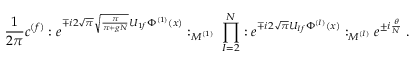Convert formula to latex. <formula><loc_0><loc_0><loc_500><loc_500>\frac { 1 } { 2 \pi } c ^ { ( f ) } \colon e ^ { \mp i 2 \sqrt { \pi } \sqrt { \frac { \pi } { \pi + g N } } U _ { 1 f } \Phi ^ { ( 1 ) } ( x ) } \colon _ { M ^ { ( 1 ) } } \, \prod _ { I = 2 } ^ { N } \colon e ^ { \mp i 2 \sqrt { \pi } U _ { I f } \Phi ^ { ( I ) } ( x ) } \colon _ { M ^ { ( I ) } } e ^ { \pm i \frac { \theta } { N } } \, .</formula> 